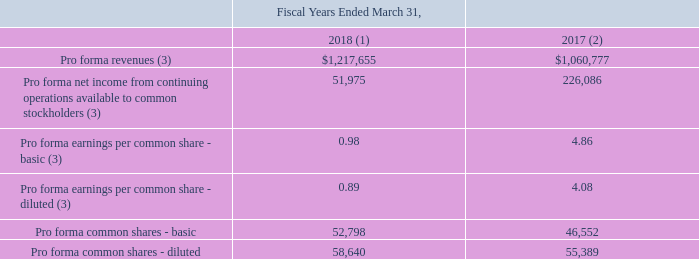Pro Forma Results
The following table summarizes, on a pro forma basis, the combined results of operations of the Company and TOKIN as though the acquisition and the Sale of EMD had occurred as of April 1, 2016. The pro forma amounts presented are not necessarily indicative of either the actual consolidated results had the acquisition occurred as of April 1, 2016, or of future consolidated operating results (amounts in thousands, except per share data):
(1) The net income for the fiscal year ended March 31, 2018 excludes the following: 34% of the gain on sale of the EMD business of $75.2 million, the gain related to the fair value of KEMET’s previous 34% interest in TOKIN of $68.7 million, and the bargain gain on the acquisition of TOKIN of $62.2 million.
(2) The net income for the fiscal year ended March 31, 2017 includes the following: 34% of the gain on sale of the EMD business of $123.4 million (which includes the release of a valuation allowance that was recorded in the fourth quarter of fiscal year 2017 and the use of the deferred tax asset which was recorded in the first quarter of fiscal year 2018), the gain related to the fair value of KEMET’s previous 34% interest in TOKIN of $66.7 million, and the bargain gain on the acquisition of TOKIN of $60.3 million.
(3) Fiscal years ended March 31, 2018 and 2017 adjusted due to the adoption of ASC 606.
How many percent of the gain on sale of the EMD business was excluded from the net income in 2018?
Answer scale should be: percent. 34. What was the pro forma revenue in 2017?
Answer scale should be: thousand. 1,060,777. What was the Pro forma common shares - diluted in 2018?
Answer scale should be: thousand. 58,640. What was the change in Pro forma revenues between 2017 and 2018? 1,217,655-1,060,777
Answer: 156878. Which years did the basic Pro forma earnings per common share exceed $1.00? (2017:4.86)
Answer: 2017. What was the percentage change in the diluted Pro forma common shares between 2017 and 2018?
Answer scale should be: percent. (58,640-55,389)/55,389
Answer: 5.87. 